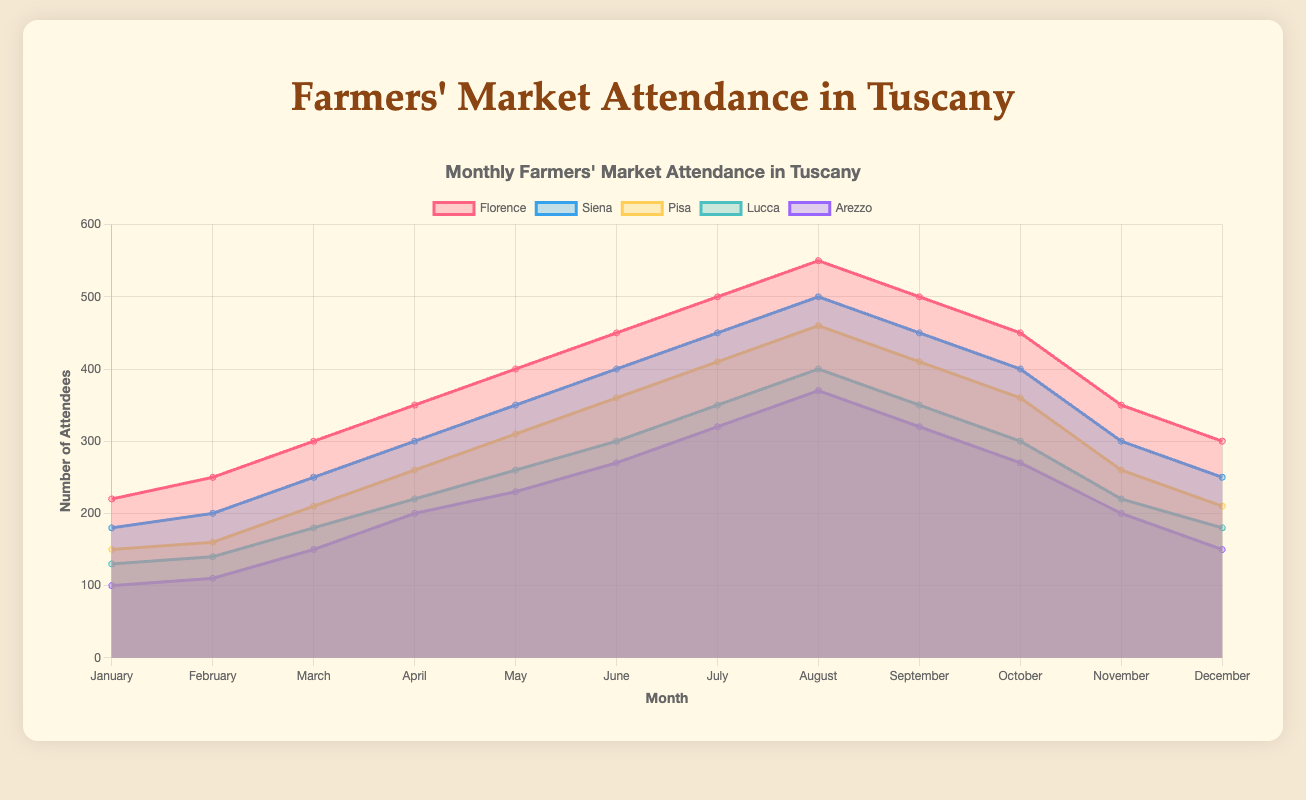What is the title of the figure? The title of the figure is located at the top and it summarizes what the figure is about.
Answer: Monthly Farmers' Market Attendance in Tuscany Which farmers' market had the lowest attendance in January? In January, the data shows the number of attendees for each market. The market with the lowest number is Arezzo with 100 attendees.
Answer: Arezzo In which month did Florence Farmers' Market reach its peak attendance? The peak attendance for Florence Farmers' Market is indicated by the highest data point in its line on the area chart. This occurs in August with 550 attendees.
Answer: August What is the average attendance of Siena Farmers' Market from January to December? To find the average attendance, add up the monthly figures for Siena and divide by 12. (180 + 200 + 250 + 300 + 350 + 400 + 450 + 500 + 450 + 400 + 300 + 250) / 12 = 3600 / 12 = 300
Answer: 300 Which two markets have equal attendance in December? Look at the data points for December. Both Pisa and Florence Farmers' Markets have 210 attendees in that month.
Answer: Pisa and Florence How does the attendance in Arezzo Farmers' Market in June compare to that in Lucca Farmers' Market in June? Check the data points for June for both markets. Arezzo has 270 attendees and Lucca has 300 attendees. Lucca has more attendees than Arezzo.
Answer: Lucca has more Across which months does the Florence Farmers' Market maintain a steady attendance of 500 or more attendees? Check the periods where Florence stays at or above 500 attendees. This occurs in July and August.
Answer: July and August What is the total attendance for the Pisa Farmers' Market in the first quarter of the year (January, February, and March)? Sum the attendance figures for Pisa from January to March. 150 (Jan) + 160 (Feb) + 210 (Mar) = 520
Answer: 520 Between April and June, which market shows the largest growth in attendance? Subtract April figures from June figures for each market and compare the differences. Florence: 450-350=100, Siena: 400-300=100, Pisa: 360-260=100, Lucca: 300-220=80, Arezzo: 270-200=70. Florence, Siena, and Pisa have the largest growth with 100 each.
Answer: Florence, Siena, and Pisa What is the overall trend in attendance across all markets from January to December? Observe the overall increase and decrease patterns in the data lines for each market over the months. There's a general increase from January to August followed by a decline towards December.
Answer: Increasing then decreasing 